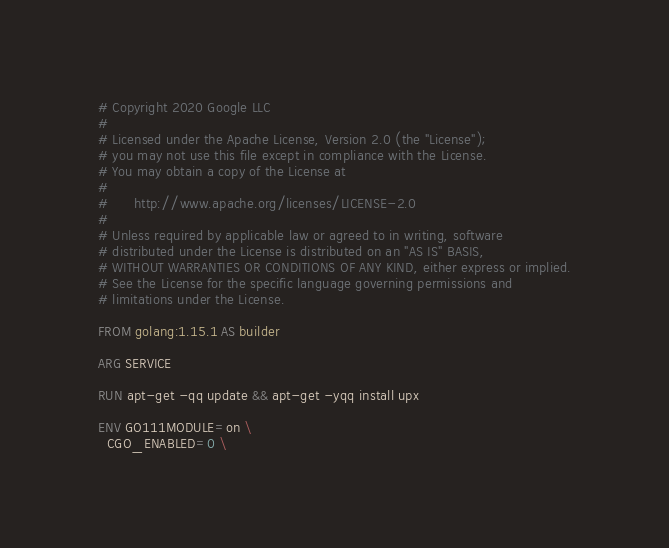<code> <loc_0><loc_0><loc_500><loc_500><_Dockerfile_># Copyright 2020 Google LLC
#
# Licensed under the Apache License, Version 2.0 (the "License");
# you may not use this file except in compliance with the License.
# You may obtain a copy of the License at
#
#      http://www.apache.org/licenses/LICENSE-2.0
#
# Unless required by applicable law or agreed to in writing, software
# distributed under the License is distributed on an "AS IS" BASIS,
# WITHOUT WARRANTIES OR CONDITIONS OF ANY KIND, either express or implied.
# See the License for the specific language governing permissions and
# limitations under the License.

FROM golang:1.15.1 AS builder

ARG SERVICE

RUN apt-get -qq update && apt-get -yqq install upx

ENV GO111MODULE=on \
  CGO_ENABLED=0 \</code> 